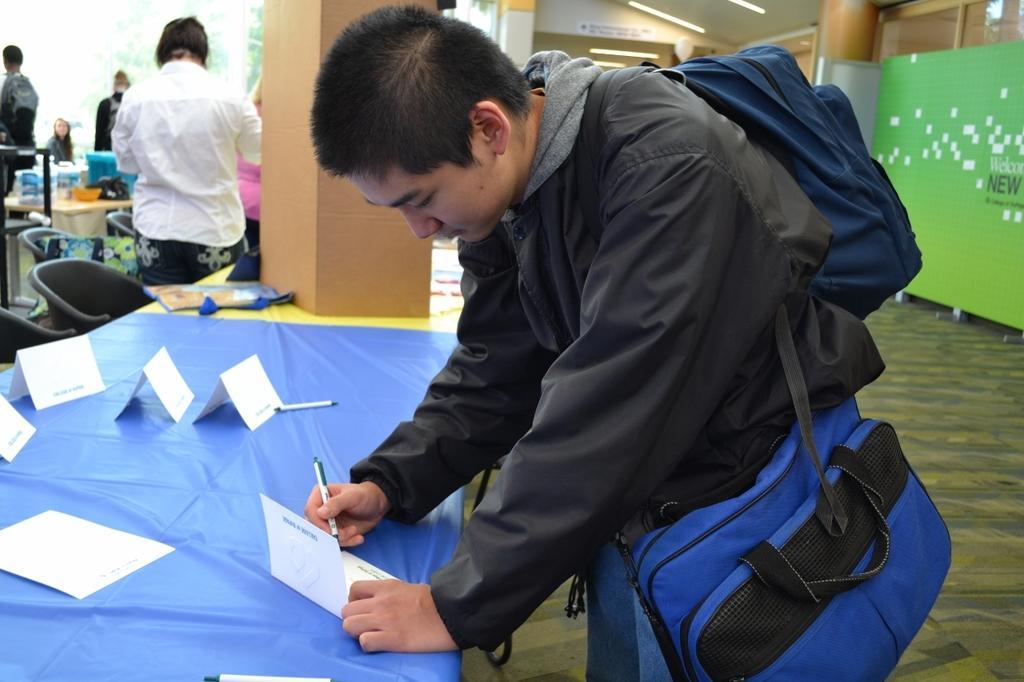Please provide a concise description of this image. In this picture I can see there is a man standing and he is wearing a bag, there is a table in front of him and there is a table and there are some pens and cards. In the backdrop I can see there is a woman standing and there are many other people standing. On the right there is a banner, a wall and a pillar and there are lights attached to the ceiling. 